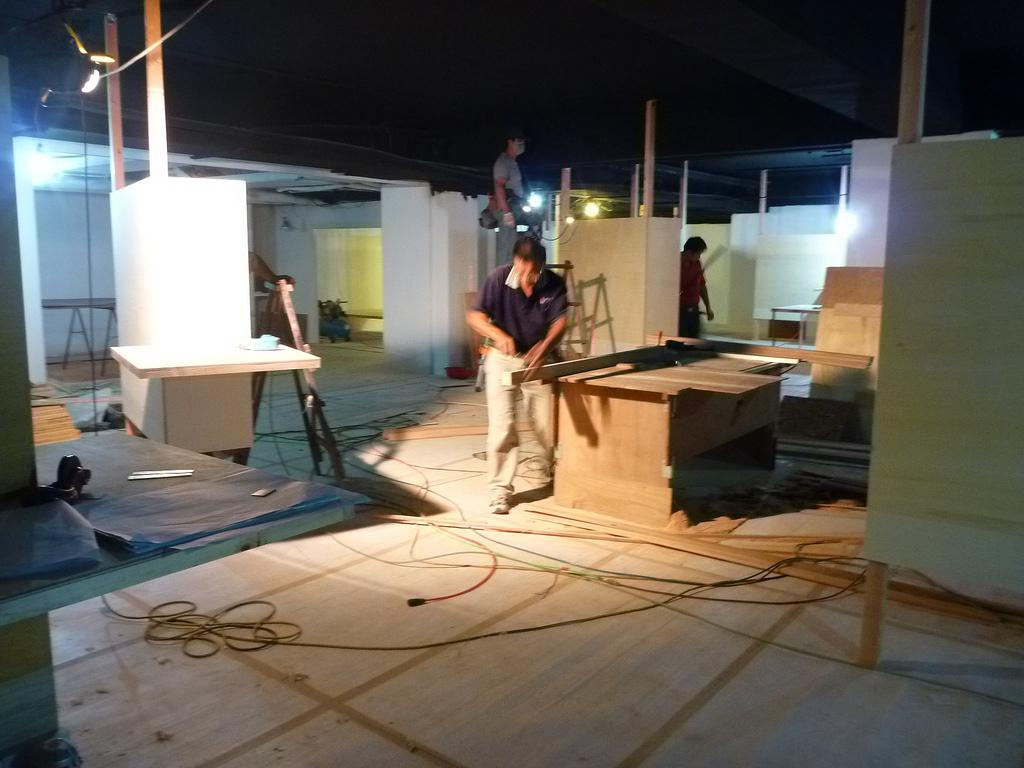What is the main activity being performed in the image? There is a man working with wood in the image. Are there any other people involved in the activity? Yes, there is another man working behind him. Can you describe the lighting conditions in the image? There is a light source in the image. How many planes are visible in the image? There are no planes visible in the image; it features two men working with wood. What type of coach can be seen in the image? There is no coach present in the image. 